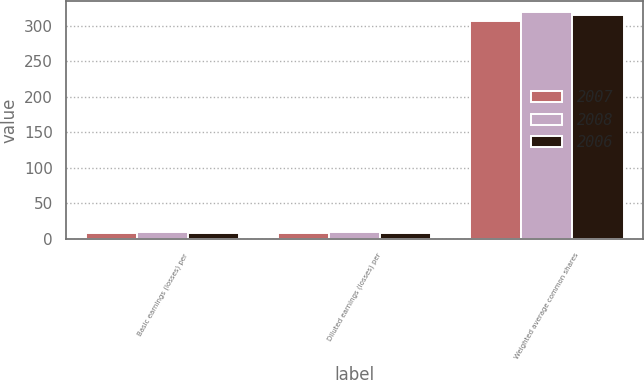Convert chart to OTSL. <chart><loc_0><loc_0><loc_500><loc_500><stacked_bar_chart><ecel><fcel>Basic earnings (losses) per<fcel>Diluted earnings (losses) per<fcel>Weighted average common shares<nl><fcel>2007<fcel>8.99<fcel>8.99<fcel>306.7<nl><fcel>2008<fcel>9.32<fcel>9.24<fcel>319.1<nl><fcel>2006<fcel>8.89<fcel>8.69<fcel>315.9<nl></chart> 